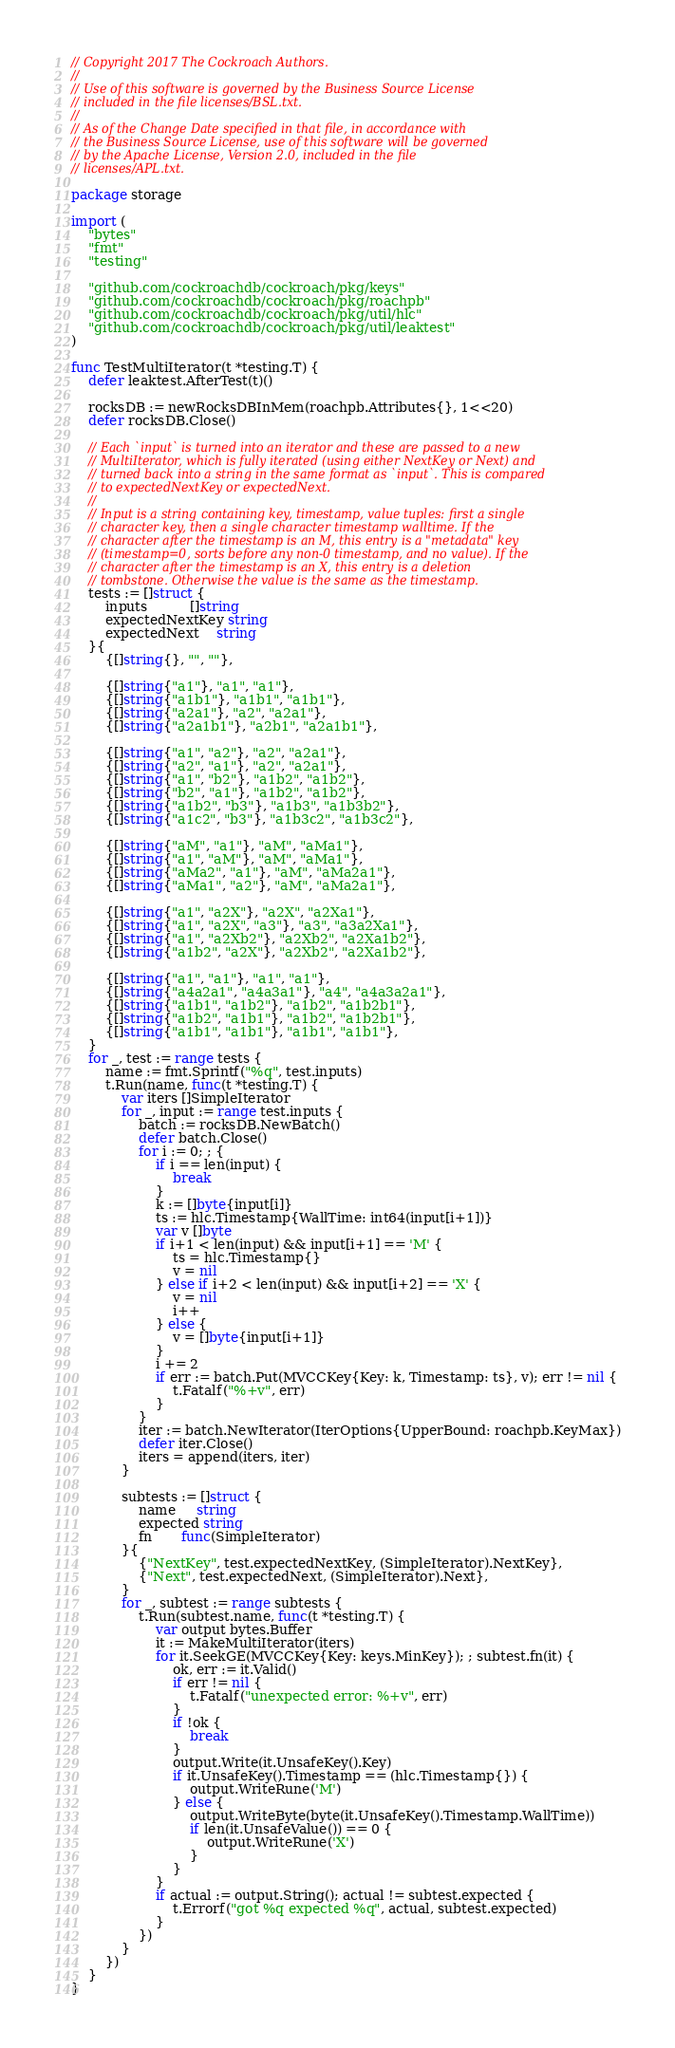<code> <loc_0><loc_0><loc_500><loc_500><_Go_>// Copyright 2017 The Cockroach Authors.
//
// Use of this software is governed by the Business Source License
// included in the file licenses/BSL.txt.
//
// As of the Change Date specified in that file, in accordance with
// the Business Source License, use of this software will be governed
// by the Apache License, Version 2.0, included in the file
// licenses/APL.txt.

package storage

import (
	"bytes"
	"fmt"
	"testing"

	"github.com/cockroachdb/cockroach/pkg/keys"
	"github.com/cockroachdb/cockroach/pkg/roachpb"
	"github.com/cockroachdb/cockroach/pkg/util/hlc"
	"github.com/cockroachdb/cockroach/pkg/util/leaktest"
)

func TestMultiIterator(t *testing.T) {
	defer leaktest.AfterTest(t)()

	rocksDB := newRocksDBInMem(roachpb.Attributes{}, 1<<20)
	defer rocksDB.Close()

	// Each `input` is turned into an iterator and these are passed to a new
	// MultiIterator, which is fully iterated (using either NextKey or Next) and
	// turned back into a string in the same format as `input`. This is compared
	// to expectedNextKey or expectedNext.
	//
	// Input is a string containing key, timestamp, value tuples: first a single
	// character key, then a single character timestamp walltime. If the
	// character after the timestamp is an M, this entry is a "metadata" key
	// (timestamp=0, sorts before any non-0 timestamp, and no value). If the
	// character after the timestamp is an X, this entry is a deletion
	// tombstone. Otherwise the value is the same as the timestamp.
	tests := []struct {
		inputs          []string
		expectedNextKey string
		expectedNext    string
	}{
		{[]string{}, "", ""},

		{[]string{"a1"}, "a1", "a1"},
		{[]string{"a1b1"}, "a1b1", "a1b1"},
		{[]string{"a2a1"}, "a2", "a2a1"},
		{[]string{"a2a1b1"}, "a2b1", "a2a1b1"},

		{[]string{"a1", "a2"}, "a2", "a2a1"},
		{[]string{"a2", "a1"}, "a2", "a2a1"},
		{[]string{"a1", "b2"}, "a1b2", "a1b2"},
		{[]string{"b2", "a1"}, "a1b2", "a1b2"},
		{[]string{"a1b2", "b3"}, "a1b3", "a1b3b2"},
		{[]string{"a1c2", "b3"}, "a1b3c2", "a1b3c2"},

		{[]string{"aM", "a1"}, "aM", "aMa1"},
		{[]string{"a1", "aM"}, "aM", "aMa1"},
		{[]string{"aMa2", "a1"}, "aM", "aMa2a1"},
		{[]string{"aMa1", "a2"}, "aM", "aMa2a1"},

		{[]string{"a1", "a2X"}, "a2X", "a2Xa1"},
		{[]string{"a1", "a2X", "a3"}, "a3", "a3a2Xa1"},
		{[]string{"a1", "a2Xb2"}, "a2Xb2", "a2Xa1b2"},
		{[]string{"a1b2", "a2X"}, "a2Xb2", "a2Xa1b2"},

		{[]string{"a1", "a1"}, "a1", "a1"},
		{[]string{"a4a2a1", "a4a3a1"}, "a4", "a4a3a2a1"},
		{[]string{"a1b1", "a1b2"}, "a1b2", "a1b2b1"},
		{[]string{"a1b2", "a1b1"}, "a1b2", "a1b2b1"},
		{[]string{"a1b1", "a1b1"}, "a1b1", "a1b1"},
	}
	for _, test := range tests {
		name := fmt.Sprintf("%q", test.inputs)
		t.Run(name, func(t *testing.T) {
			var iters []SimpleIterator
			for _, input := range test.inputs {
				batch := rocksDB.NewBatch()
				defer batch.Close()
				for i := 0; ; {
					if i == len(input) {
						break
					}
					k := []byte{input[i]}
					ts := hlc.Timestamp{WallTime: int64(input[i+1])}
					var v []byte
					if i+1 < len(input) && input[i+1] == 'M' {
						ts = hlc.Timestamp{}
						v = nil
					} else if i+2 < len(input) && input[i+2] == 'X' {
						v = nil
						i++
					} else {
						v = []byte{input[i+1]}
					}
					i += 2
					if err := batch.Put(MVCCKey{Key: k, Timestamp: ts}, v); err != nil {
						t.Fatalf("%+v", err)
					}
				}
				iter := batch.NewIterator(IterOptions{UpperBound: roachpb.KeyMax})
				defer iter.Close()
				iters = append(iters, iter)
			}

			subtests := []struct {
				name     string
				expected string
				fn       func(SimpleIterator)
			}{
				{"NextKey", test.expectedNextKey, (SimpleIterator).NextKey},
				{"Next", test.expectedNext, (SimpleIterator).Next},
			}
			for _, subtest := range subtests {
				t.Run(subtest.name, func(t *testing.T) {
					var output bytes.Buffer
					it := MakeMultiIterator(iters)
					for it.SeekGE(MVCCKey{Key: keys.MinKey}); ; subtest.fn(it) {
						ok, err := it.Valid()
						if err != nil {
							t.Fatalf("unexpected error: %+v", err)
						}
						if !ok {
							break
						}
						output.Write(it.UnsafeKey().Key)
						if it.UnsafeKey().Timestamp == (hlc.Timestamp{}) {
							output.WriteRune('M')
						} else {
							output.WriteByte(byte(it.UnsafeKey().Timestamp.WallTime))
							if len(it.UnsafeValue()) == 0 {
								output.WriteRune('X')
							}
						}
					}
					if actual := output.String(); actual != subtest.expected {
						t.Errorf("got %q expected %q", actual, subtest.expected)
					}
				})
			}
		})
	}
}
</code> 